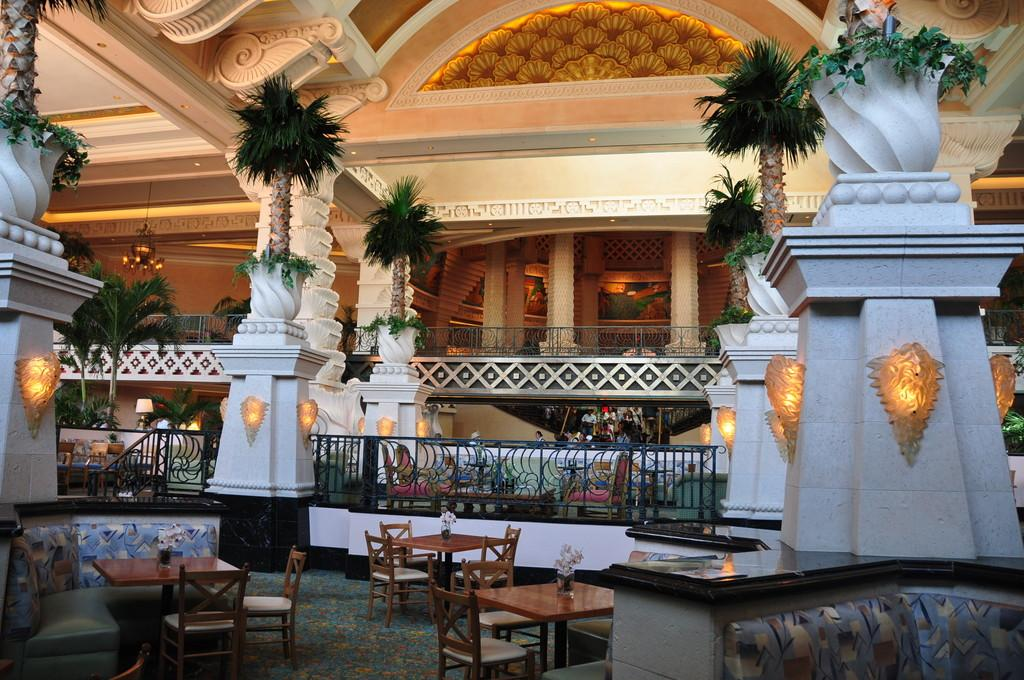What is the main structure in the image? There is a huge building in the image. What can be found inside the building? There are tables and chairs inside the building. What type of natural elements can be seen in the image? There are trees visible in the image. What time of day is it in the image, as indicated by the presence of a flame? There is no flame present in the image, so we cannot determine the time of day based on that. 